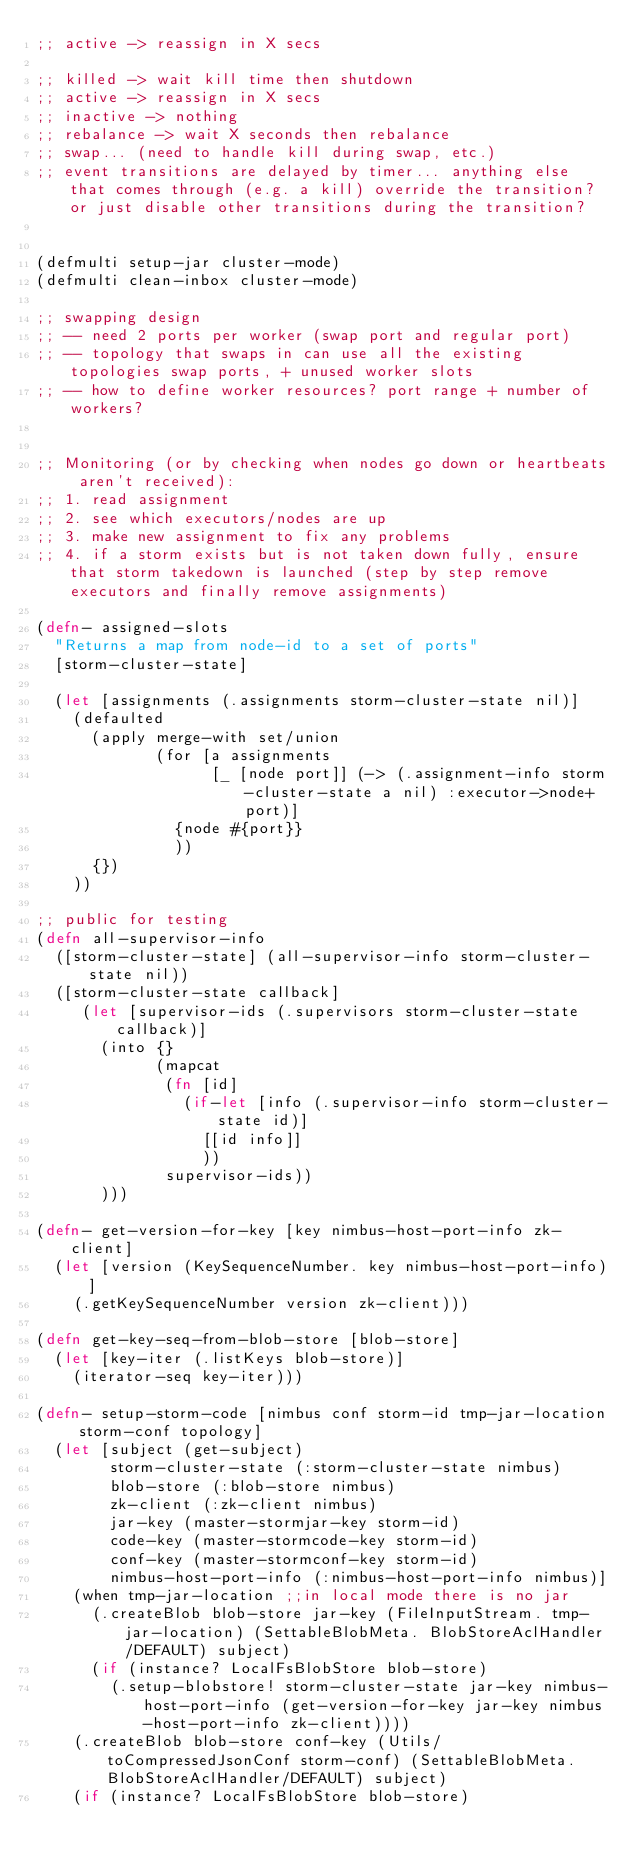Convert code to text. <code><loc_0><loc_0><loc_500><loc_500><_Clojure_>;; active -> reassign in X secs

;; killed -> wait kill time then shutdown
;; active -> reassign in X secs
;; inactive -> nothing
;; rebalance -> wait X seconds then rebalance
;; swap... (need to handle kill during swap, etc.)
;; event transitions are delayed by timer... anything else that comes through (e.g. a kill) override the transition? or just disable other transitions during the transition?


(defmulti setup-jar cluster-mode)
(defmulti clean-inbox cluster-mode)

;; swapping design
;; -- need 2 ports per worker (swap port and regular port)
;; -- topology that swaps in can use all the existing topologies swap ports, + unused worker slots
;; -- how to define worker resources? port range + number of workers?


;; Monitoring (or by checking when nodes go down or heartbeats aren't received):
;; 1. read assignment
;; 2. see which executors/nodes are up
;; 3. make new assignment to fix any problems
;; 4. if a storm exists but is not taken down fully, ensure that storm takedown is launched (step by step remove executors and finally remove assignments)

(defn- assigned-slots
  "Returns a map from node-id to a set of ports"
  [storm-cluster-state]

  (let [assignments (.assignments storm-cluster-state nil)]
    (defaulted
      (apply merge-with set/union
             (for [a assignments
                   [_ [node port]] (-> (.assignment-info storm-cluster-state a nil) :executor->node+port)]
               {node #{port}}
               ))
      {})
    ))

;; public for testing
(defn all-supervisor-info
  ([storm-cluster-state] (all-supervisor-info storm-cluster-state nil))
  ([storm-cluster-state callback]
     (let [supervisor-ids (.supervisors storm-cluster-state callback)]
       (into {}
             (mapcat
              (fn [id]
                (if-let [info (.supervisor-info storm-cluster-state id)]
                  [[id info]]
                  ))
              supervisor-ids))
       )))

(defn- get-version-for-key [key nimbus-host-port-info zk-client]
  (let [version (KeySequenceNumber. key nimbus-host-port-info)]
    (.getKeySequenceNumber version zk-client)))

(defn get-key-seq-from-blob-store [blob-store]
  (let [key-iter (.listKeys blob-store)]
    (iterator-seq key-iter)))

(defn- setup-storm-code [nimbus conf storm-id tmp-jar-location storm-conf topology]
  (let [subject (get-subject)
        storm-cluster-state (:storm-cluster-state nimbus)
        blob-store (:blob-store nimbus)
        zk-client (:zk-client nimbus)
        jar-key (master-stormjar-key storm-id)
        code-key (master-stormcode-key storm-id)
        conf-key (master-stormconf-key storm-id)
        nimbus-host-port-info (:nimbus-host-port-info nimbus)]
    (when tmp-jar-location ;;in local mode there is no jar
      (.createBlob blob-store jar-key (FileInputStream. tmp-jar-location) (SettableBlobMeta. BlobStoreAclHandler/DEFAULT) subject)
      (if (instance? LocalFsBlobStore blob-store)
        (.setup-blobstore! storm-cluster-state jar-key nimbus-host-port-info (get-version-for-key jar-key nimbus-host-port-info zk-client))))
    (.createBlob blob-store conf-key (Utils/toCompressedJsonConf storm-conf) (SettableBlobMeta. BlobStoreAclHandler/DEFAULT) subject)
    (if (instance? LocalFsBlobStore blob-store)</code> 